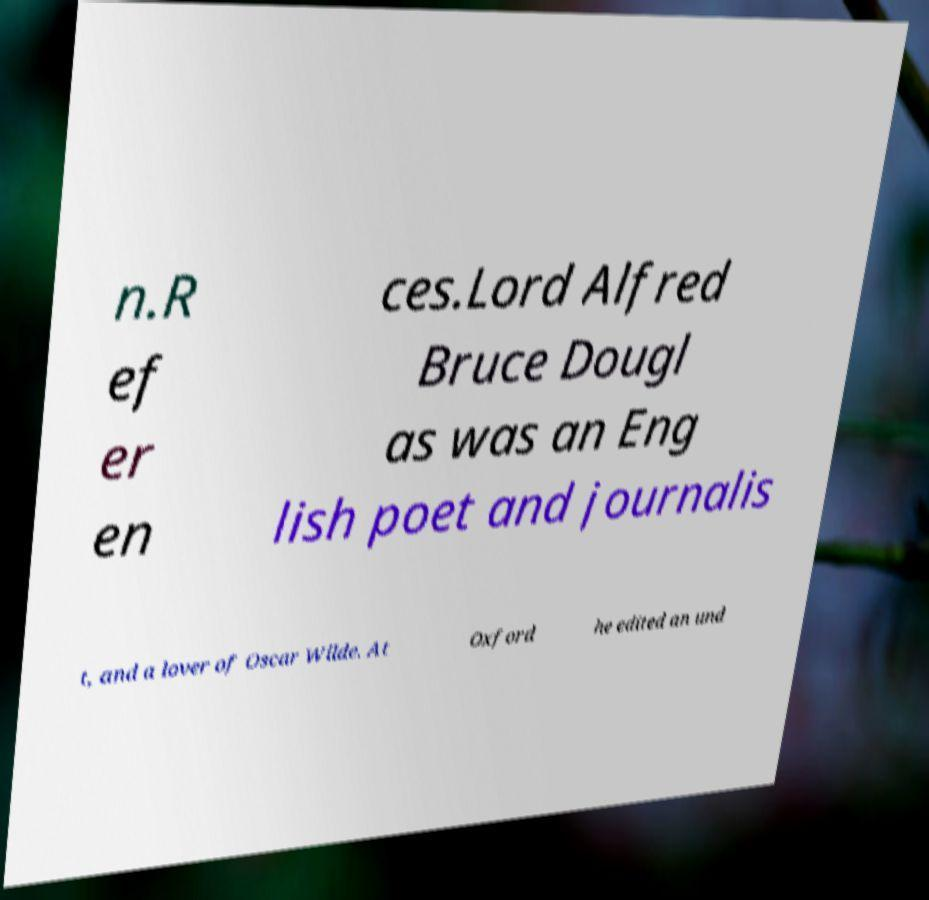Can you read and provide the text displayed in the image?This photo seems to have some interesting text. Can you extract and type it out for me? n.R ef er en ces.Lord Alfred Bruce Dougl as was an Eng lish poet and journalis t, and a lover of Oscar Wilde. At Oxford he edited an und 